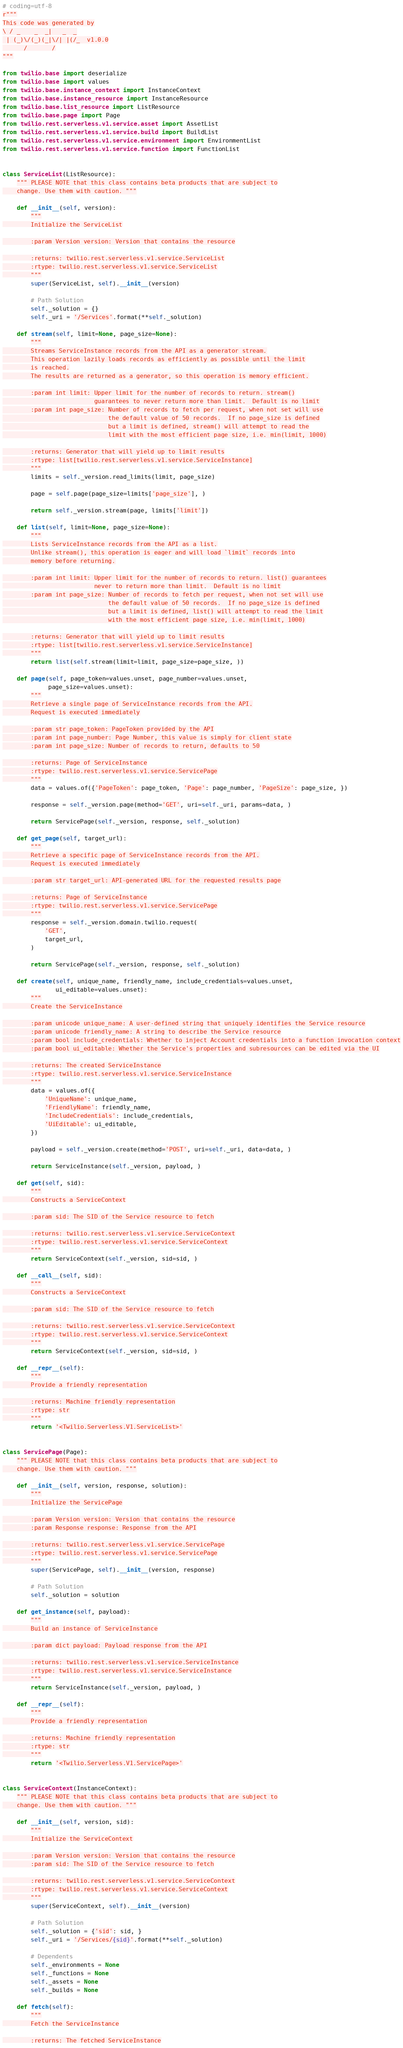Convert code to text. <code><loc_0><loc_0><loc_500><loc_500><_Python_># coding=utf-8
r"""
This code was generated by
\ / _    _  _|   _  _
 | (_)\/(_)(_|\/| |(/_  v1.0.0
      /       /
"""

from twilio.base import deserialize
from twilio.base import values
from twilio.base.instance_context import InstanceContext
from twilio.base.instance_resource import InstanceResource
from twilio.base.list_resource import ListResource
from twilio.base.page import Page
from twilio.rest.serverless.v1.service.asset import AssetList
from twilio.rest.serverless.v1.service.build import BuildList
from twilio.rest.serverless.v1.service.environment import EnvironmentList
from twilio.rest.serverless.v1.service.function import FunctionList


class ServiceList(ListResource):
    """ PLEASE NOTE that this class contains beta products that are subject to
    change. Use them with caution. """

    def __init__(self, version):
        """
        Initialize the ServiceList

        :param Version version: Version that contains the resource

        :returns: twilio.rest.serverless.v1.service.ServiceList
        :rtype: twilio.rest.serverless.v1.service.ServiceList
        """
        super(ServiceList, self).__init__(version)

        # Path Solution
        self._solution = {}
        self._uri = '/Services'.format(**self._solution)

    def stream(self, limit=None, page_size=None):
        """
        Streams ServiceInstance records from the API as a generator stream.
        This operation lazily loads records as efficiently as possible until the limit
        is reached.
        The results are returned as a generator, so this operation is memory efficient.

        :param int limit: Upper limit for the number of records to return. stream()
                          guarantees to never return more than limit.  Default is no limit
        :param int page_size: Number of records to fetch per request, when not set will use
                              the default value of 50 records.  If no page_size is defined
                              but a limit is defined, stream() will attempt to read the
                              limit with the most efficient page size, i.e. min(limit, 1000)

        :returns: Generator that will yield up to limit results
        :rtype: list[twilio.rest.serverless.v1.service.ServiceInstance]
        """
        limits = self._version.read_limits(limit, page_size)

        page = self.page(page_size=limits['page_size'], )

        return self._version.stream(page, limits['limit'])

    def list(self, limit=None, page_size=None):
        """
        Lists ServiceInstance records from the API as a list.
        Unlike stream(), this operation is eager and will load `limit` records into
        memory before returning.

        :param int limit: Upper limit for the number of records to return. list() guarantees
                          never to return more than limit.  Default is no limit
        :param int page_size: Number of records to fetch per request, when not set will use
                              the default value of 50 records.  If no page_size is defined
                              but a limit is defined, list() will attempt to read the limit
                              with the most efficient page size, i.e. min(limit, 1000)

        :returns: Generator that will yield up to limit results
        :rtype: list[twilio.rest.serverless.v1.service.ServiceInstance]
        """
        return list(self.stream(limit=limit, page_size=page_size, ))

    def page(self, page_token=values.unset, page_number=values.unset,
             page_size=values.unset):
        """
        Retrieve a single page of ServiceInstance records from the API.
        Request is executed immediately

        :param str page_token: PageToken provided by the API
        :param int page_number: Page Number, this value is simply for client state
        :param int page_size: Number of records to return, defaults to 50

        :returns: Page of ServiceInstance
        :rtype: twilio.rest.serverless.v1.service.ServicePage
        """
        data = values.of({'PageToken': page_token, 'Page': page_number, 'PageSize': page_size, })

        response = self._version.page(method='GET', uri=self._uri, params=data, )

        return ServicePage(self._version, response, self._solution)

    def get_page(self, target_url):
        """
        Retrieve a specific page of ServiceInstance records from the API.
        Request is executed immediately

        :param str target_url: API-generated URL for the requested results page

        :returns: Page of ServiceInstance
        :rtype: twilio.rest.serverless.v1.service.ServicePage
        """
        response = self._version.domain.twilio.request(
            'GET',
            target_url,
        )

        return ServicePage(self._version, response, self._solution)

    def create(self, unique_name, friendly_name, include_credentials=values.unset,
               ui_editable=values.unset):
        """
        Create the ServiceInstance

        :param unicode unique_name: A user-defined string that uniquely identifies the Service resource
        :param unicode friendly_name: A string to describe the Service resource
        :param bool include_credentials: Whether to inject Account credentials into a function invocation context
        :param bool ui_editable: Whether the Service's properties and subresources can be edited via the UI

        :returns: The created ServiceInstance
        :rtype: twilio.rest.serverless.v1.service.ServiceInstance
        """
        data = values.of({
            'UniqueName': unique_name,
            'FriendlyName': friendly_name,
            'IncludeCredentials': include_credentials,
            'UiEditable': ui_editable,
        })

        payload = self._version.create(method='POST', uri=self._uri, data=data, )

        return ServiceInstance(self._version, payload, )

    def get(self, sid):
        """
        Constructs a ServiceContext

        :param sid: The SID of the Service resource to fetch

        :returns: twilio.rest.serverless.v1.service.ServiceContext
        :rtype: twilio.rest.serverless.v1.service.ServiceContext
        """
        return ServiceContext(self._version, sid=sid, )

    def __call__(self, sid):
        """
        Constructs a ServiceContext

        :param sid: The SID of the Service resource to fetch

        :returns: twilio.rest.serverless.v1.service.ServiceContext
        :rtype: twilio.rest.serverless.v1.service.ServiceContext
        """
        return ServiceContext(self._version, sid=sid, )

    def __repr__(self):
        """
        Provide a friendly representation

        :returns: Machine friendly representation
        :rtype: str
        """
        return '<Twilio.Serverless.V1.ServiceList>'


class ServicePage(Page):
    """ PLEASE NOTE that this class contains beta products that are subject to
    change. Use them with caution. """

    def __init__(self, version, response, solution):
        """
        Initialize the ServicePage

        :param Version version: Version that contains the resource
        :param Response response: Response from the API

        :returns: twilio.rest.serverless.v1.service.ServicePage
        :rtype: twilio.rest.serverless.v1.service.ServicePage
        """
        super(ServicePage, self).__init__(version, response)

        # Path Solution
        self._solution = solution

    def get_instance(self, payload):
        """
        Build an instance of ServiceInstance

        :param dict payload: Payload response from the API

        :returns: twilio.rest.serverless.v1.service.ServiceInstance
        :rtype: twilio.rest.serverless.v1.service.ServiceInstance
        """
        return ServiceInstance(self._version, payload, )

    def __repr__(self):
        """
        Provide a friendly representation

        :returns: Machine friendly representation
        :rtype: str
        """
        return '<Twilio.Serverless.V1.ServicePage>'


class ServiceContext(InstanceContext):
    """ PLEASE NOTE that this class contains beta products that are subject to
    change. Use them with caution. """

    def __init__(self, version, sid):
        """
        Initialize the ServiceContext

        :param Version version: Version that contains the resource
        :param sid: The SID of the Service resource to fetch

        :returns: twilio.rest.serverless.v1.service.ServiceContext
        :rtype: twilio.rest.serverless.v1.service.ServiceContext
        """
        super(ServiceContext, self).__init__(version)

        # Path Solution
        self._solution = {'sid': sid, }
        self._uri = '/Services/{sid}'.format(**self._solution)

        # Dependents
        self._environments = None
        self._functions = None
        self._assets = None
        self._builds = None

    def fetch(self):
        """
        Fetch the ServiceInstance

        :returns: The fetched ServiceInstance</code> 